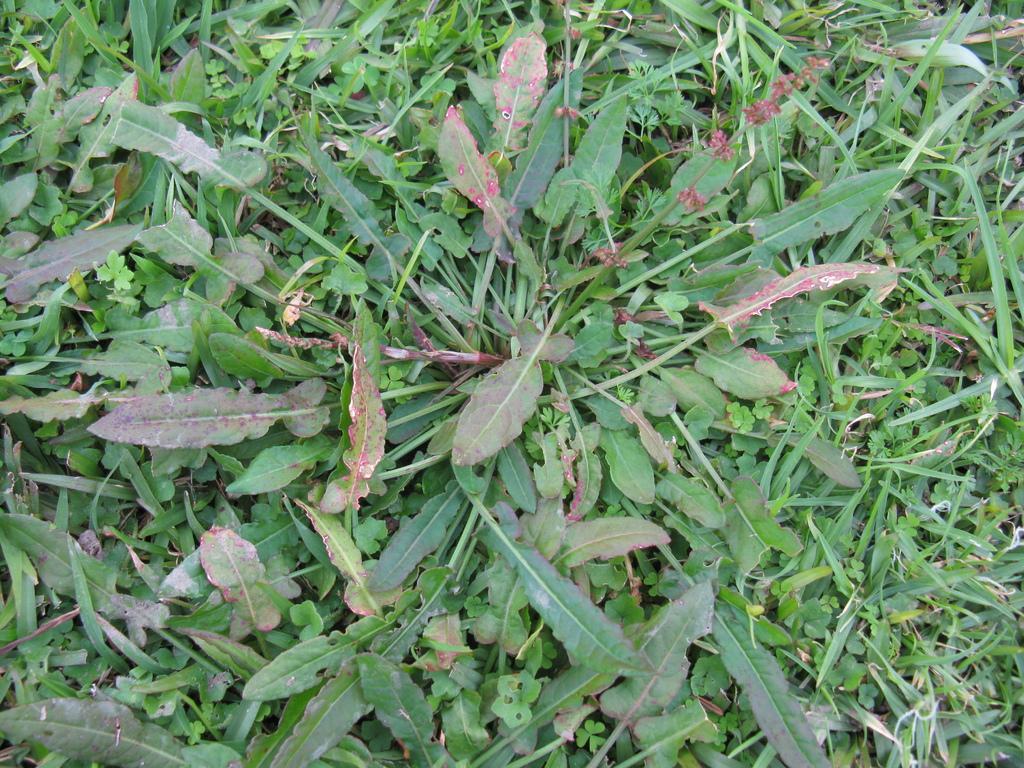How would you summarize this image in a sentence or two? These are the plants and there is the grass in this image. 